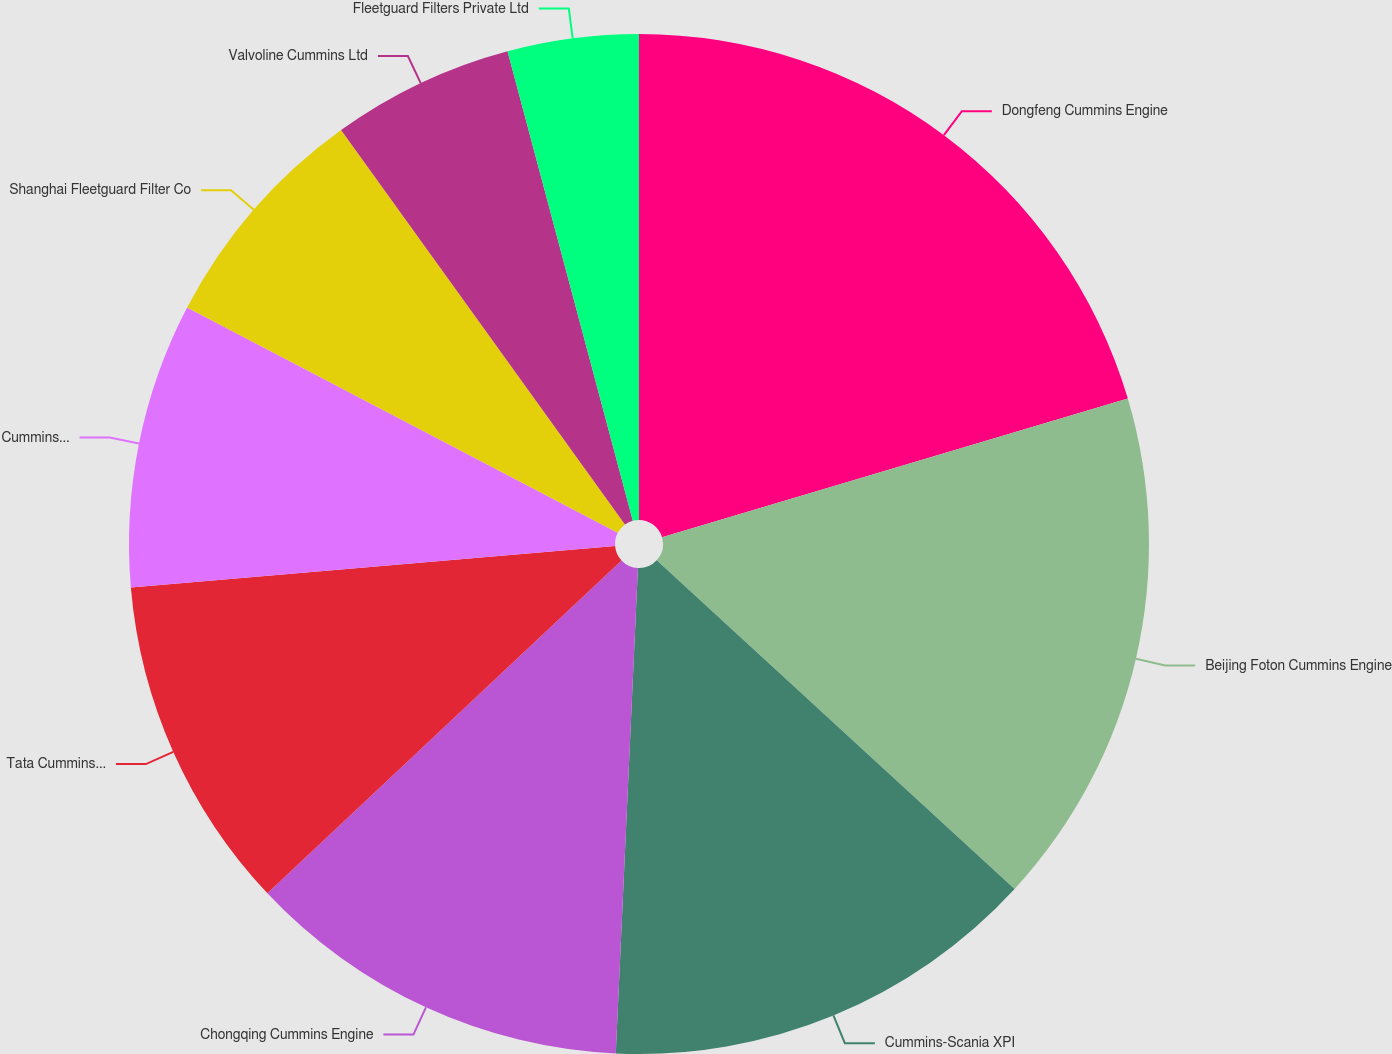Convert chart to OTSL. <chart><loc_0><loc_0><loc_500><loc_500><pie_chart><fcel>Dongfeng Cummins Engine<fcel>Beijing Foton Cummins Engine<fcel>Cummins-Scania XPI<fcel>Chongqing Cummins Engine<fcel>Tata Cummins Ltd<fcel>Cummins Olayan Energy<fcel>Shanghai Fleetguard Filter Co<fcel>Valvoline Cummins Ltd<fcel>Fleetguard Filters Private Ltd<nl><fcel>20.4%<fcel>16.43%<fcel>13.9%<fcel>12.27%<fcel>10.65%<fcel>9.03%<fcel>7.4%<fcel>5.78%<fcel>4.15%<nl></chart> 